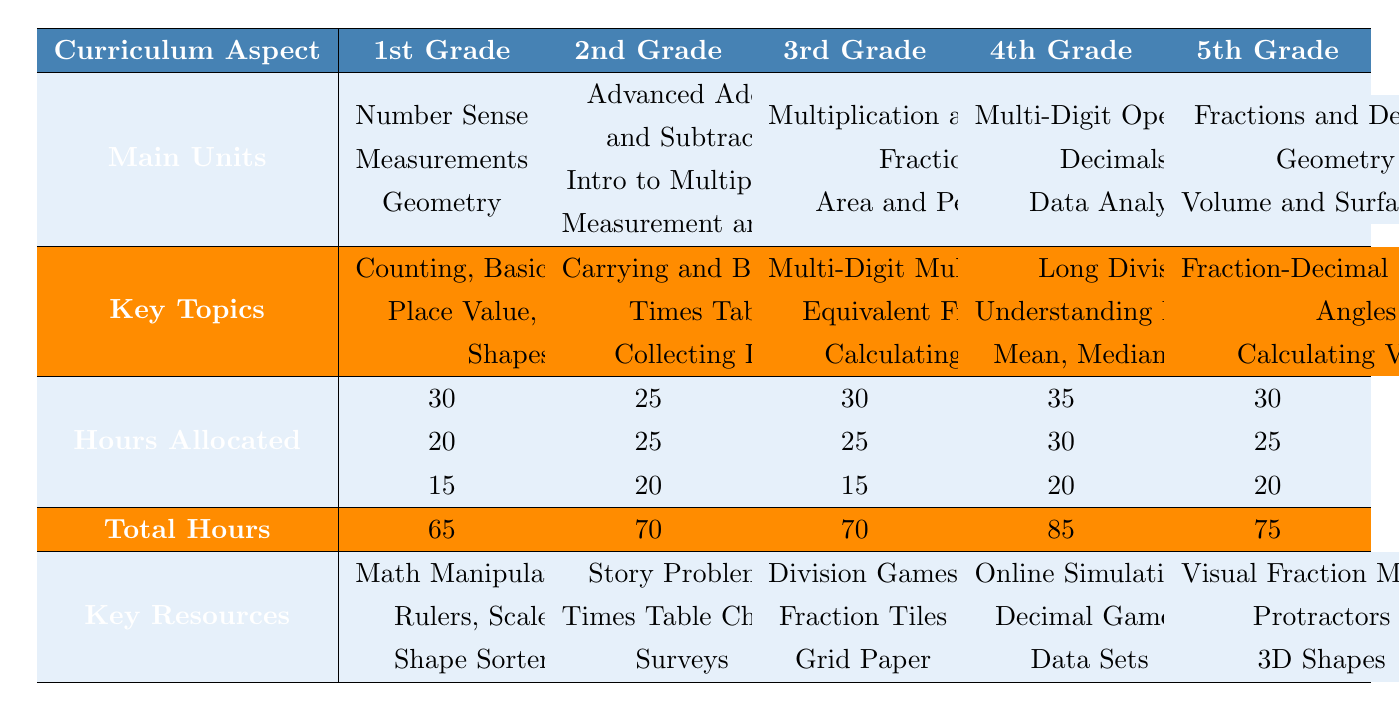What is the total hours allocated for 4th Grade math curriculum coverage? The total hours for 4th Grade is listed as 85 in the 'Total Hours' row of the table.
Answer: 85 Which grade level has the least total hours allocated for math curriculum coverage? By comparing the total hours for all grade levels: 1st Grade (65), 2nd Grade (70), 3rd Grade (70), 4th Grade (85), 5th Grade (75), the least total hours is for 1st Grade.
Answer: 1st Grade How many units are covered in 5th Grade? The table indicates there are three units listed under 'Main Units' for 5th Grade: Fractions and Decimals, Geometry, and Volume and Surface Area.
Answer: 3 Is the topic "Shapes" included in the math curriculum for 2nd Grade? The 2nd Grade covers topics including "Carrying and Borrowing", "Times Tables", and "Collecting Data", but does not include "Shapes". Thus, the answer is no.
Answer: No What is the difference in total hours allocated between 3rd Grade and 1st Grade? The total hours for 3rd Grade is 70 and for 1st Grade is 65. To find the difference, subtract 65 from 70, which equals 5.
Answer: 5 List the topics covered in the 4th Grade under the "Decimals" unit. The 4th Grade 'Decimals' unit covers "Understanding Decimals" and "Addition and Subtraction of Decimals".
Answer: Understanding Decimals, Addition and Subtraction of Decimals Which grade has the highest focus on Geometry, and what are its topics? 5th Grade has the highest focus on Geometry among the grades, covering "Angles" and "Types of Triangles".
Answer: 5th Grade; Angles, Types of Triangles What is the sum of hours allocated for all three units in the 1st Grade? The hours allocated in 1st Grade are 30 for Number Sense, 20 for Measurements, and 15 for Geometry. Adding these values gives us 30 + 20 + 15 = 65 hours.
Answer: 65 For which grade is "Fractions" a unit, and what are the key topics included in it? "Fractions" is a unit for both 3rd Grade and 5th Grade. In 3rd Grade, the topics are "Equivalent Fractions" and "Adding and Subtracting Fractions". In 5th Grade, topics cover "Conversion Between Fractions and Decimals" and "Operations".
Answer: 3rd Grade; Equivalent Fractions, Adding and Subtracting Fractions; 5th Grade; Conversion Between Fractions and Decimals, Operations Which unit in 2nd Grade has the same hours allocated as the unit in 5th Grade that covers Geometry? The Introduction to Multiplication in 2nd Grade has 25 hours allocated, which matches the 25 hours allocated for the Geometry unit in 5th Grade.
Answer: Advanced Addition and Subtraction/Introduction to Multiplication, Geometry Which grade has a total hours allocation that is less by 5 hours than the grade immediately above it? Comparing the total hours: 1st Grade (65), 2nd Grade (70), 3rd Grade (70), 4th Grade (85), 5th Grade (75). The 1st Grade is 5 hours less than the 2nd Grade.
Answer: 1st Grade How many total units are covered across all grade levels? Counting the units in each grade: 3 (1st) + 3 (2nd) + 3 (3rd) + 3 (4th) + 3 (5th) equals 15.
Answer: 15 